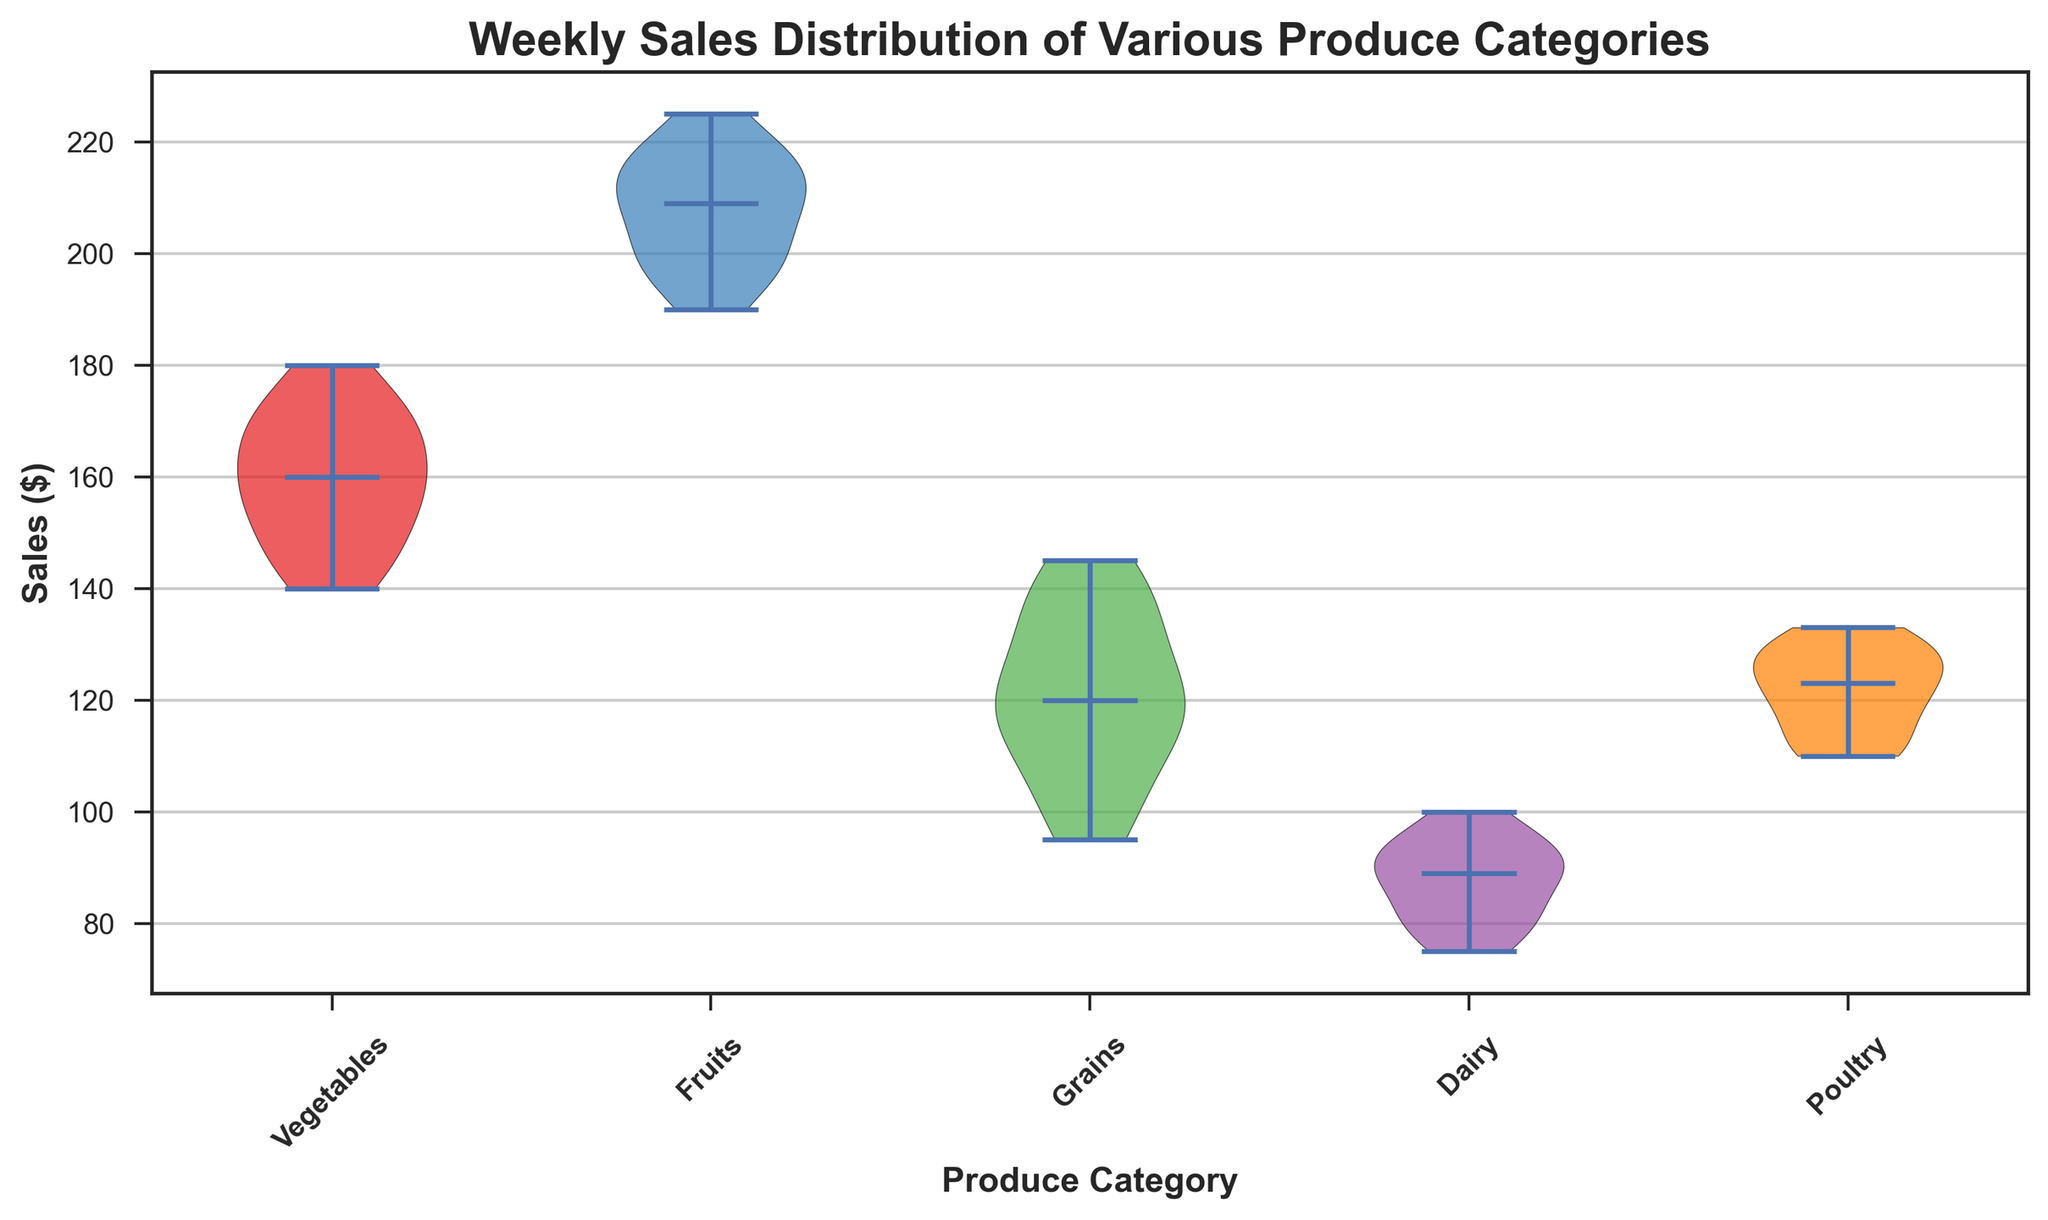What is the range of weekly sales for Dairy produce? By looking at the spread of the shape above the 'Dairy' category on the x-axis, the range is determined by the highest and lowest points of the violin plot. The weekly sales for Dairy range from the minimum to the maximum values shown.
Answer: 75 to 100 Which produce category has the widest spread in sales? The width of the violin plot indicates the spread or variability in the data. By comparing the width of each category's violin plot, the category with the widest spread in the sales distribution is the one whose plot is the widest
Answer: Grains What is the median sales value for Fruits? The violin plot has a line representing the median in the center of each category's plot. The position of this line within the Fruits plot indicates the median sales value.
Answer: 210 Compare the median sales value of Vegetables and Poultry. Which one is higher? By observing the median lines within the Violin plots for Vegetables and Poultry, and comparing their positions on the y-axis, the one that is higher indicates a greater median value.
Answer: Vegetables Are there any categories where the majority of the sales data are concentrated around the upper range? This can be inferred by the concentration and shape of the violin plots. If the upper part of the plot is thicker, it indicates a concentration of values in the upper range.
Answer: Yes, Fruits and Grains Is the median sales value of Poultry closer to Vegetables or Dairy? By visually inspecting the median lines of the Poultry, Vegetables, and Dairy categories, and comparing their positions on the y-axis, we can see which median is closer to that of Poultry.
Answer: Dairy Among the categories, which one has the lowest maximum sales value? The topmost point of each category's violin plot represents the maximum sales value. By comparing these points among all categories, we find the lowest one.
Answer: Dairy Which category has the smallest interquartile range in its weekly sales distribution? The interquartile range is visually represented by the middle 50% of the data within the violin plot. Comparing the height of the thickest part of each plot, the category with the smallest height has the smallest interquartile range.
Answer: Vegetables 